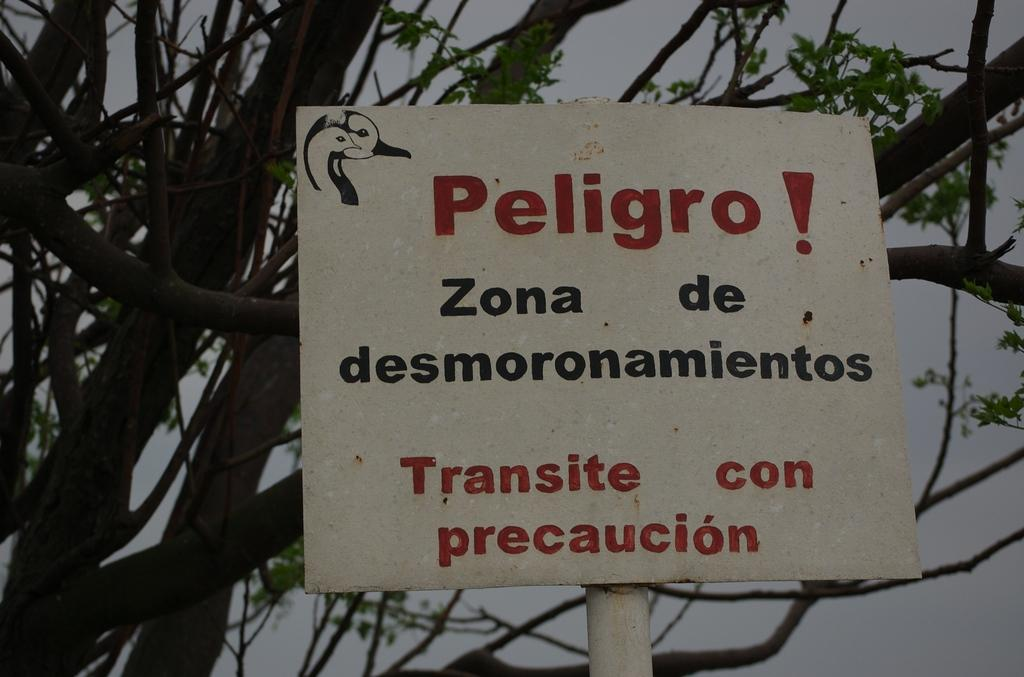What is on the pole in the image? There is a board on a pole in the image. What can be found on the board? The board contains text and bird images. What is visible in the background of the image? There are trees and the sky in the background of the image. What type of vein is visible in the image? There is no vein present in the image. What story is being told by the bird images on the board? The image does not provide any information about a story being told by the bird images; it only shows their presence on the board. 